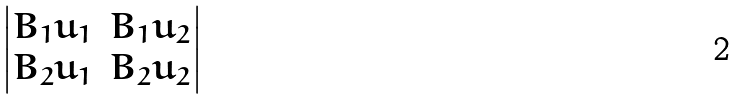<formula> <loc_0><loc_0><loc_500><loc_500>\begin{vmatrix} B _ { 1 } u _ { 1 } & B _ { 1 } u _ { 2 } \\ B _ { 2 } u _ { 1 } & B _ { 2 } u _ { 2 } \end{vmatrix}</formula> 